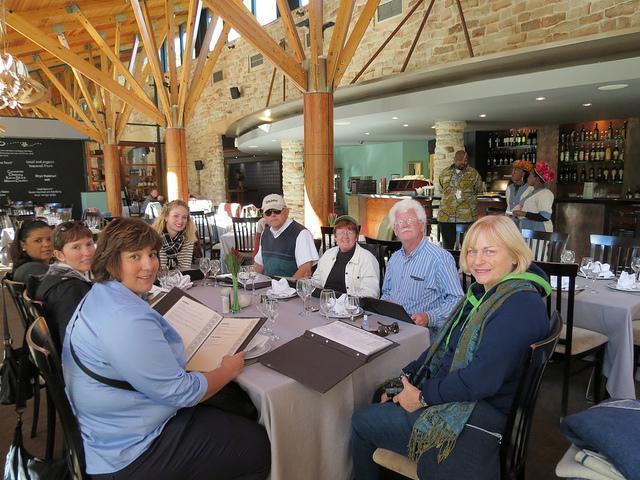How many handbags are in the photo?
Give a very brief answer. 2. How many dining tables are in the photo?
Give a very brief answer. 2. How many people are there?
Give a very brief answer. 9. How many chairs are there?
Give a very brief answer. 5. How many zebras are there?
Give a very brief answer. 0. 